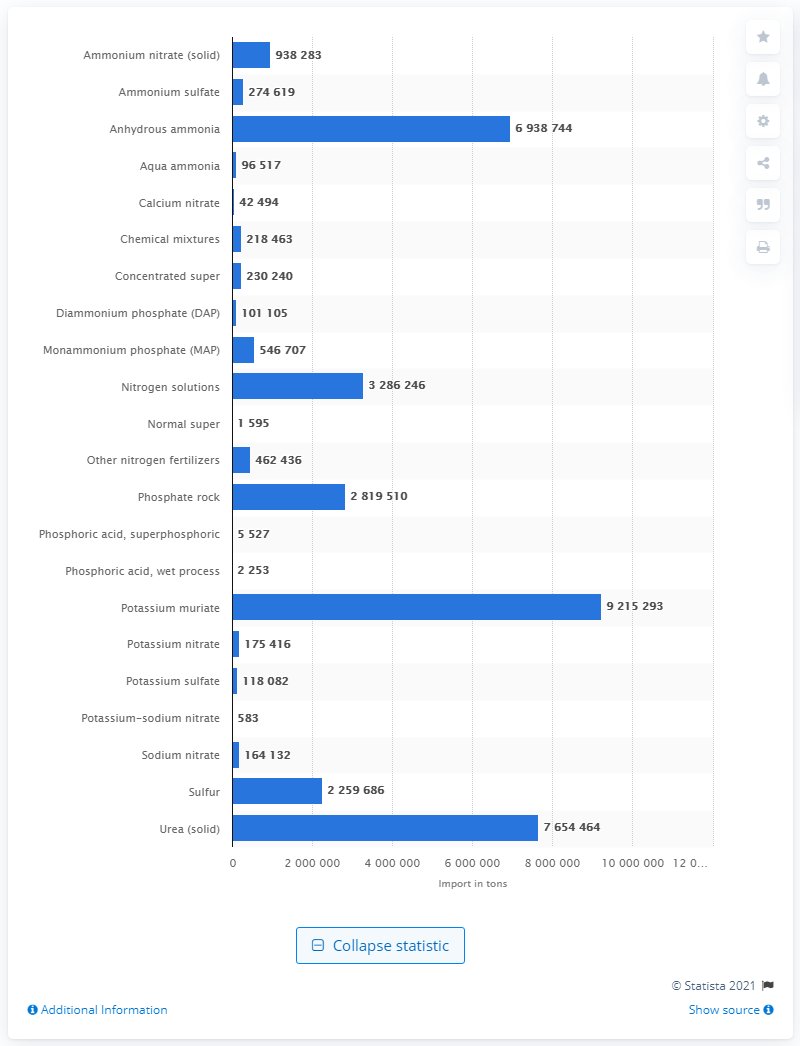Draw attention to some important aspects in this diagram. In 2012, a total of 921,529.3 metric tons of potassium muriate were imported into the United States. 